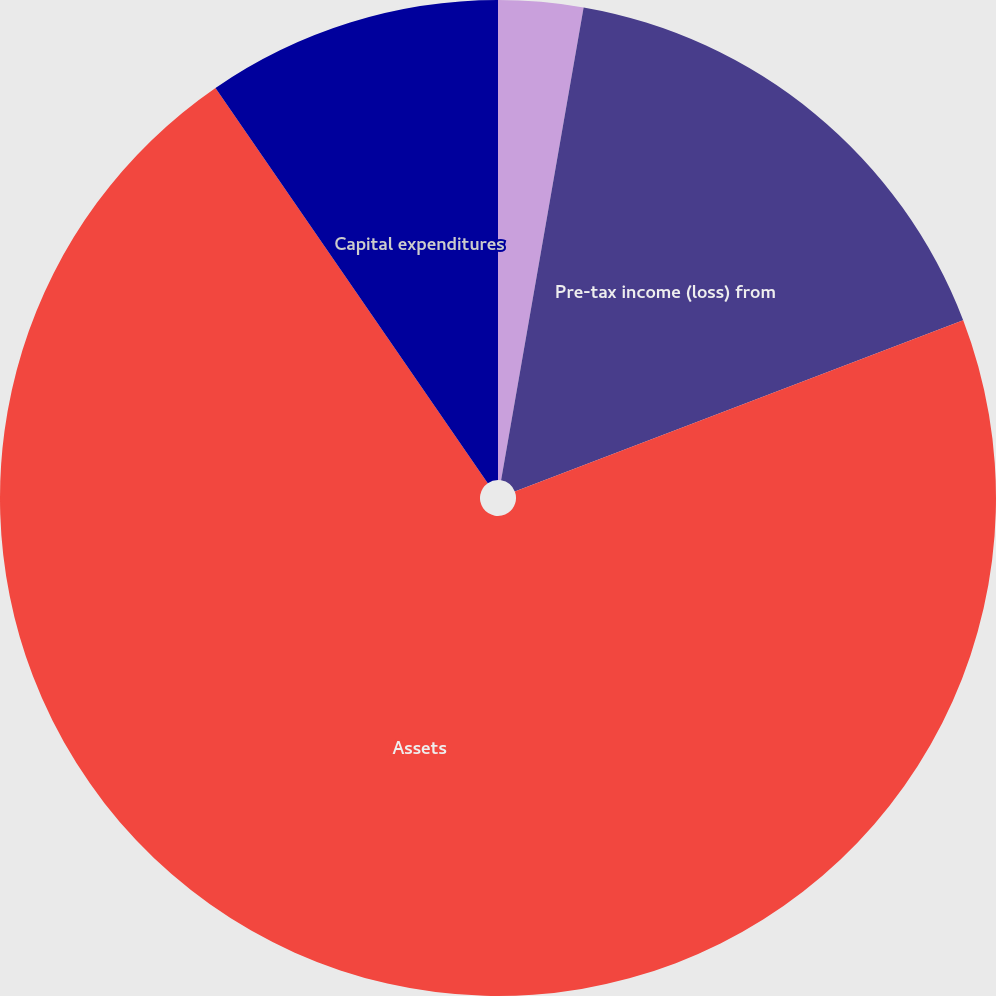<chart> <loc_0><loc_0><loc_500><loc_500><pie_chart><fcel>Depreciation and amortization<fcel>Pre-tax income (loss) from<fcel>Assets<fcel>Capital expenditures<nl><fcel>2.75%<fcel>16.44%<fcel>71.21%<fcel>9.6%<nl></chart> 